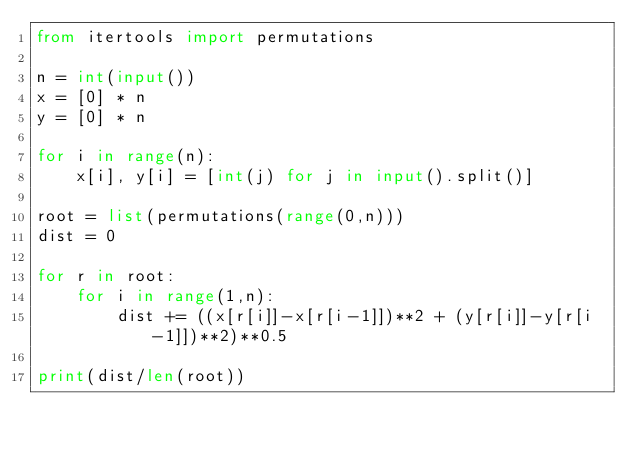Convert code to text. <code><loc_0><loc_0><loc_500><loc_500><_Python_>from itertools import permutations

n = int(input())
x = [0] * n
y = [0] * n

for i in range(n):
    x[i], y[i] = [int(j) for j in input().split()]

root = list(permutations(range(0,n)))
dist = 0

for r in root:
    for i in range(1,n):
        dist += ((x[r[i]]-x[r[i-1]])**2 + (y[r[i]]-y[r[i-1]])**2)**0.5

print(dist/len(root))</code> 